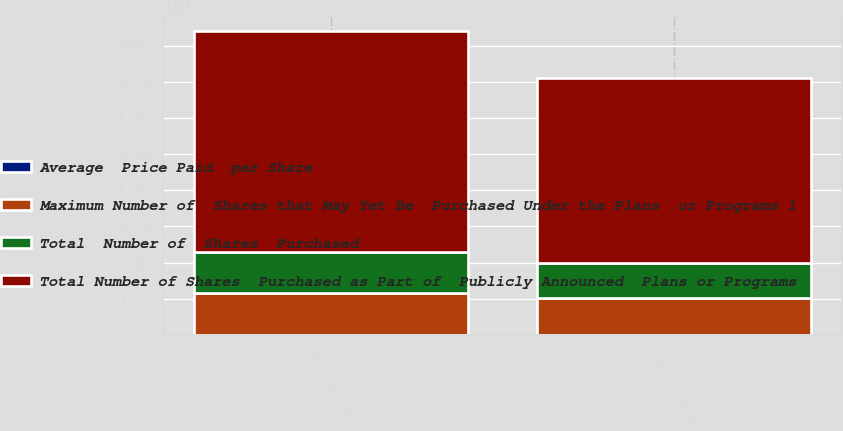Convert chart to OTSL. <chart><loc_0><loc_0><loc_500><loc_500><stacked_bar_chart><ecel><fcel>July 31 to Sept 3 2011<fcel>Sept 4 to Oct 1 2011 Total<nl><fcel>Maximum Number of  Shares that May Yet Be  Purchased Under the Plans  or Programs 1<fcel>2.91961e+06<fcel>2.52415e+06<nl><fcel>Average  Price Paid  per Share<fcel>16.97<fcel>17.16<nl><fcel>Total  Number of  Shares  Purchased<fcel>2.80748e+06<fcel>2.4698e+06<nl><fcel>Total Number of Shares  Purchased as Part of  Publicly Announced  Plans or Programs<fcel>1.52636e+07<fcel>1.27938e+07<nl></chart> 